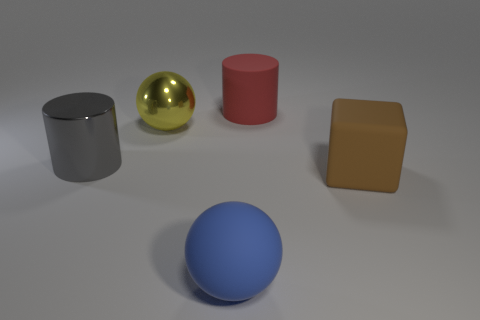The object that is right of the large gray shiny thing and to the left of the large blue rubber sphere is what color?
Your answer should be very brief. Yellow. How many large cyan spheres are there?
Ensure brevity in your answer.  0. Is the yellow thing made of the same material as the cube?
Provide a short and direct response. No. There is a big matte object behind the cylinder left of the big red rubber cylinder that is right of the gray shiny object; what shape is it?
Offer a very short reply. Cylinder. Does the cylinder to the left of the blue sphere have the same material as the ball in front of the yellow sphere?
Make the answer very short. No. What is the brown thing made of?
Offer a very short reply. Rubber. What number of large gray metal objects are the same shape as the large red rubber thing?
Make the answer very short. 1. Are there any other things that are the same shape as the gray object?
Give a very brief answer. Yes. What color is the big cylinder that is behind the big metallic object that is behind the cylinder that is on the left side of the rubber cylinder?
Provide a succinct answer. Red. How many big objects are blue cubes or matte cylinders?
Make the answer very short. 1. 